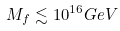<formula> <loc_0><loc_0><loc_500><loc_500>M _ { f } \lesssim 1 0 ^ { 1 6 } G e V</formula> 